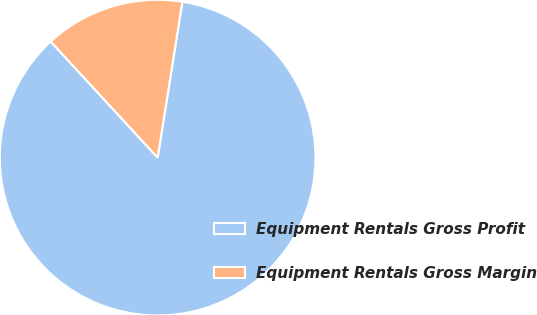<chart> <loc_0><loc_0><loc_500><loc_500><pie_chart><fcel>Equipment Rentals Gross Profit<fcel>Equipment Rentals Gross Margin<nl><fcel>85.65%<fcel>14.35%<nl></chart> 